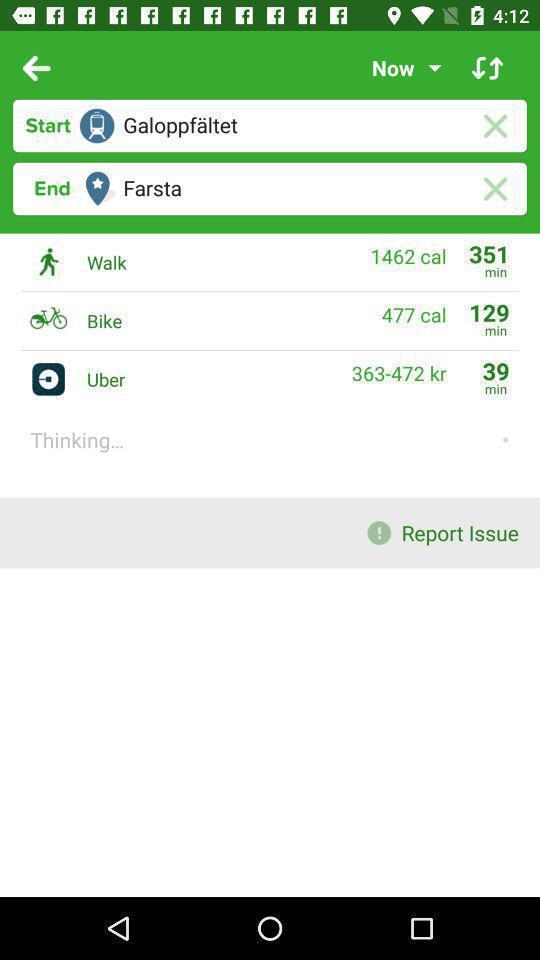What can you discern from this picture? Screen shows multiple options of travel application. 